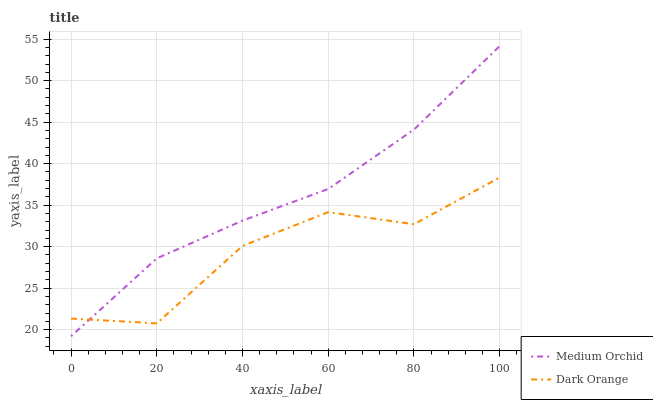Does Dark Orange have the minimum area under the curve?
Answer yes or no. Yes. Does Medium Orchid have the maximum area under the curve?
Answer yes or no. Yes. Does Medium Orchid have the minimum area under the curve?
Answer yes or no. No. Is Medium Orchid the smoothest?
Answer yes or no. Yes. Is Dark Orange the roughest?
Answer yes or no. Yes. Is Medium Orchid the roughest?
Answer yes or no. No. Does Medium Orchid have the lowest value?
Answer yes or no. Yes. Does Medium Orchid have the highest value?
Answer yes or no. Yes. Does Medium Orchid intersect Dark Orange?
Answer yes or no. Yes. Is Medium Orchid less than Dark Orange?
Answer yes or no. No. Is Medium Orchid greater than Dark Orange?
Answer yes or no. No. 